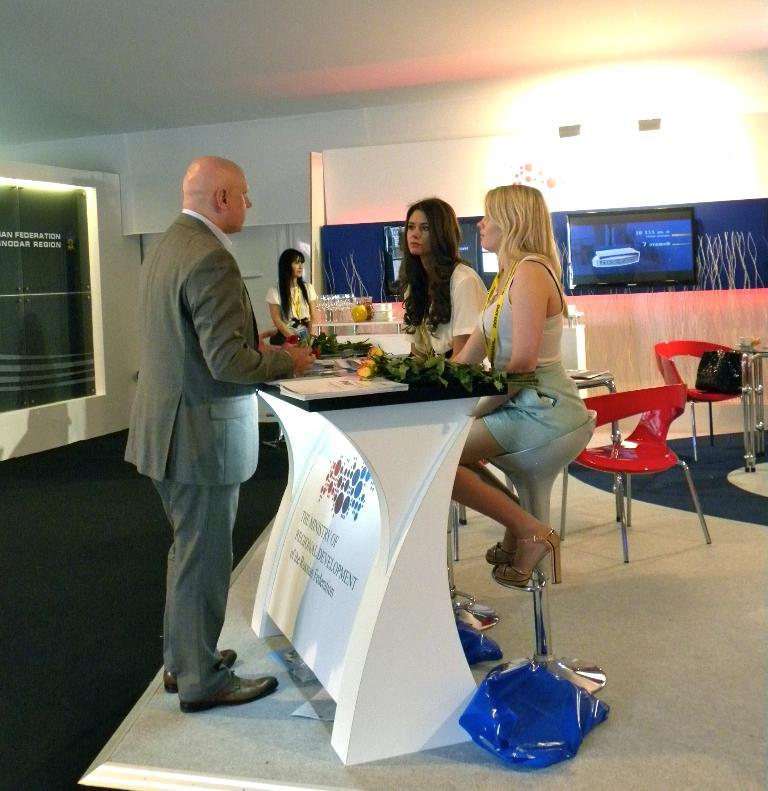What type of structure can be seen in the image? There is a wall in the image. What type of furniture is present in the image? There are chairs and tables in the image. How many people are in the image? There are four people in the image. What is on the table in the image? There are food items on the table. What type of wrench is being used by the people in the image? There is no wrench present in the image; the people are not using any tools. How many sisters are in the image? There is no information about the relationships between the people in the image, so we cannot determine the number of sisters. 